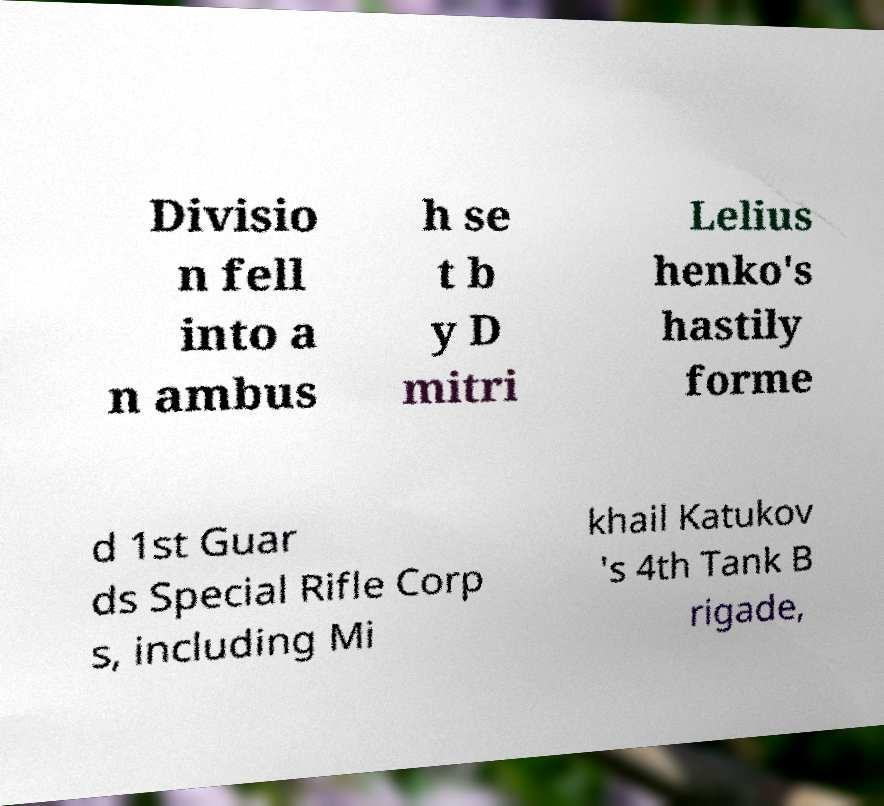Can you accurately transcribe the text from the provided image for me? Divisio n fell into a n ambus h se t b y D mitri Lelius henko's hastily forme d 1st Guar ds Special Rifle Corp s, including Mi khail Katukov 's 4th Tank B rigade, 